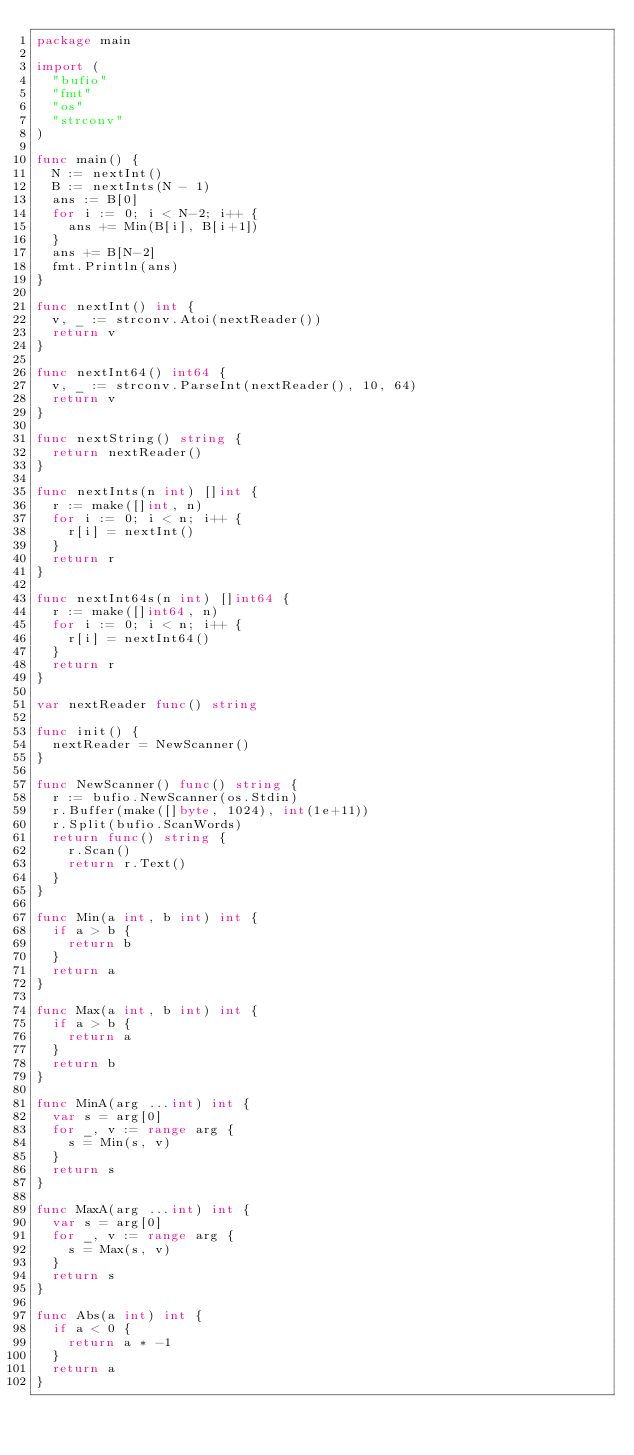<code> <loc_0><loc_0><loc_500><loc_500><_Go_>package main

import (
	"bufio"
	"fmt"
	"os"
	"strconv"
)

func main() {
	N := nextInt()
	B := nextInts(N - 1)
	ans := B[0]
	for i := 0; i < N-2; i++ {
		ans += Min(B[i], B[i+1])
	}
	ans += B[N-2]
	fmt.Println(ans)
}

func nextInt() int {
	v, _ := strconv.Atoi(nextReader())
	return v
}

func nextInt64() int64 {
	v, _ := strconv.ParseInt(nextReader(), 10, 64)
	return v
}

func nextString() string {
	return nextReader()
}

func nextInts(n int) []int {
	r := make([]int, n)
	for i := 0; i < n; i++ {
		r[i] = nextInt()
	}
	return r
}

func nextInt64s(n int) []int64 {
	r := make([]int64, n)
	for i := 0; i < n; i++ {
		r[i] = nextInt64()
	}
	return r
}

var nextReader func() string

func init() {
	nextReader = NewScanner()
}

func NewScanner() func() string {
	r := bufio.NewScanner(os.Stdin)
	r.Buffer(make([]byte, 1024), int(1e+11))
	r.Split(bufio.ScanWords)
	return func() string {
		r.Scan()
		return r.Text()
	}
}

func Min(a int, b int) int {
	if a > b {
		return b
	}
	return a
}

func Max(a int, b int) int {
	if a > b {
		return a
	}
	return b
}

func MinA(arg ...int) int {
	var s = arg[0]
	for _, v := range arg {
		s = Min(s, v)
	}
	return s
}

func MaxA(arg ...int) int {
	var s = arg[0]
	for _, v := range arg {
		s = Max(s, v)
	}
	return s
}

func Abs(a int) int {
	if a < 0 {
		return a * -1
	}
	return a
}
</code> 